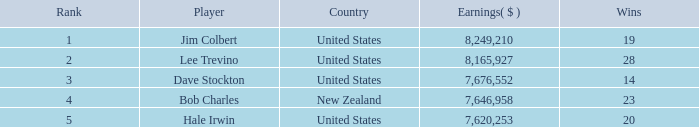How many players named bob charles with earnings over $7,646,958? 0.0. 